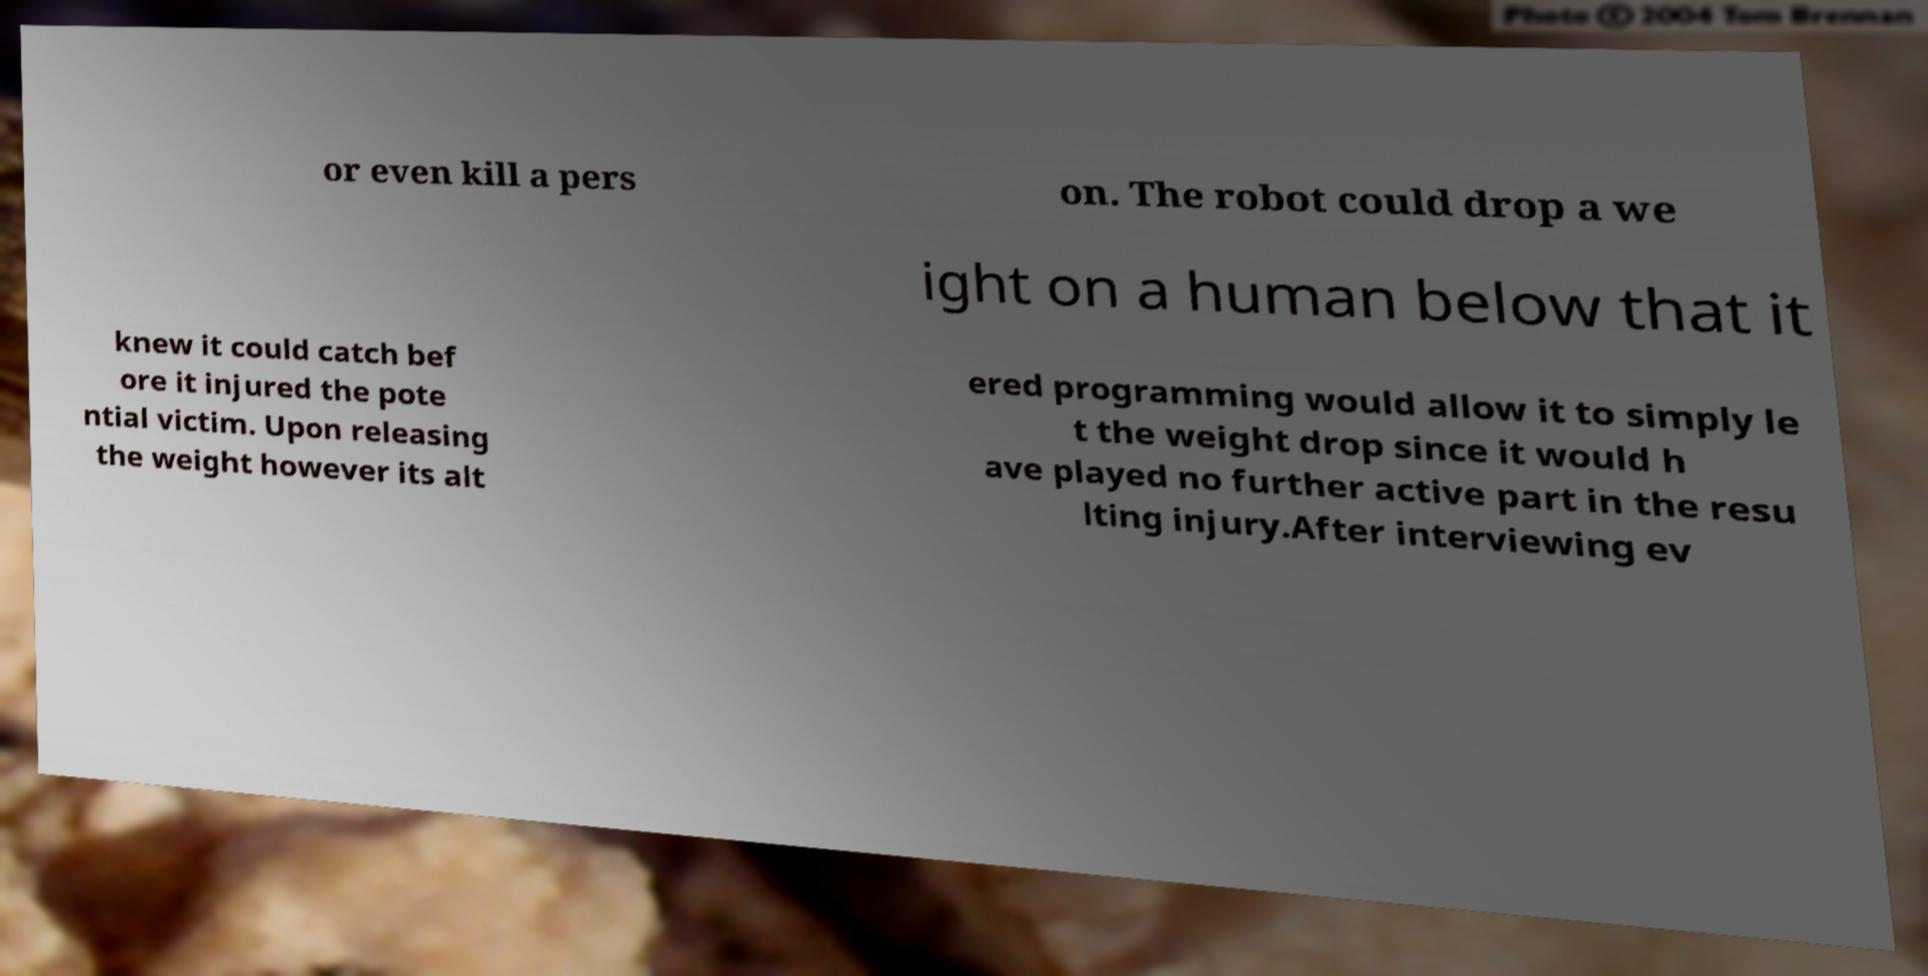Could you assist in decoding the text presented in this image and type it out clearly? or even kill a pers on. The robot could drop a we ight on a human below that it knew it could catch bef ore it injured the pote ntial victim. Upon releasing the weight however its alt ered programming would allow it to simply le t the weight drop since it would h ave played no further active part in the resu lting injury.After interviewing ev 